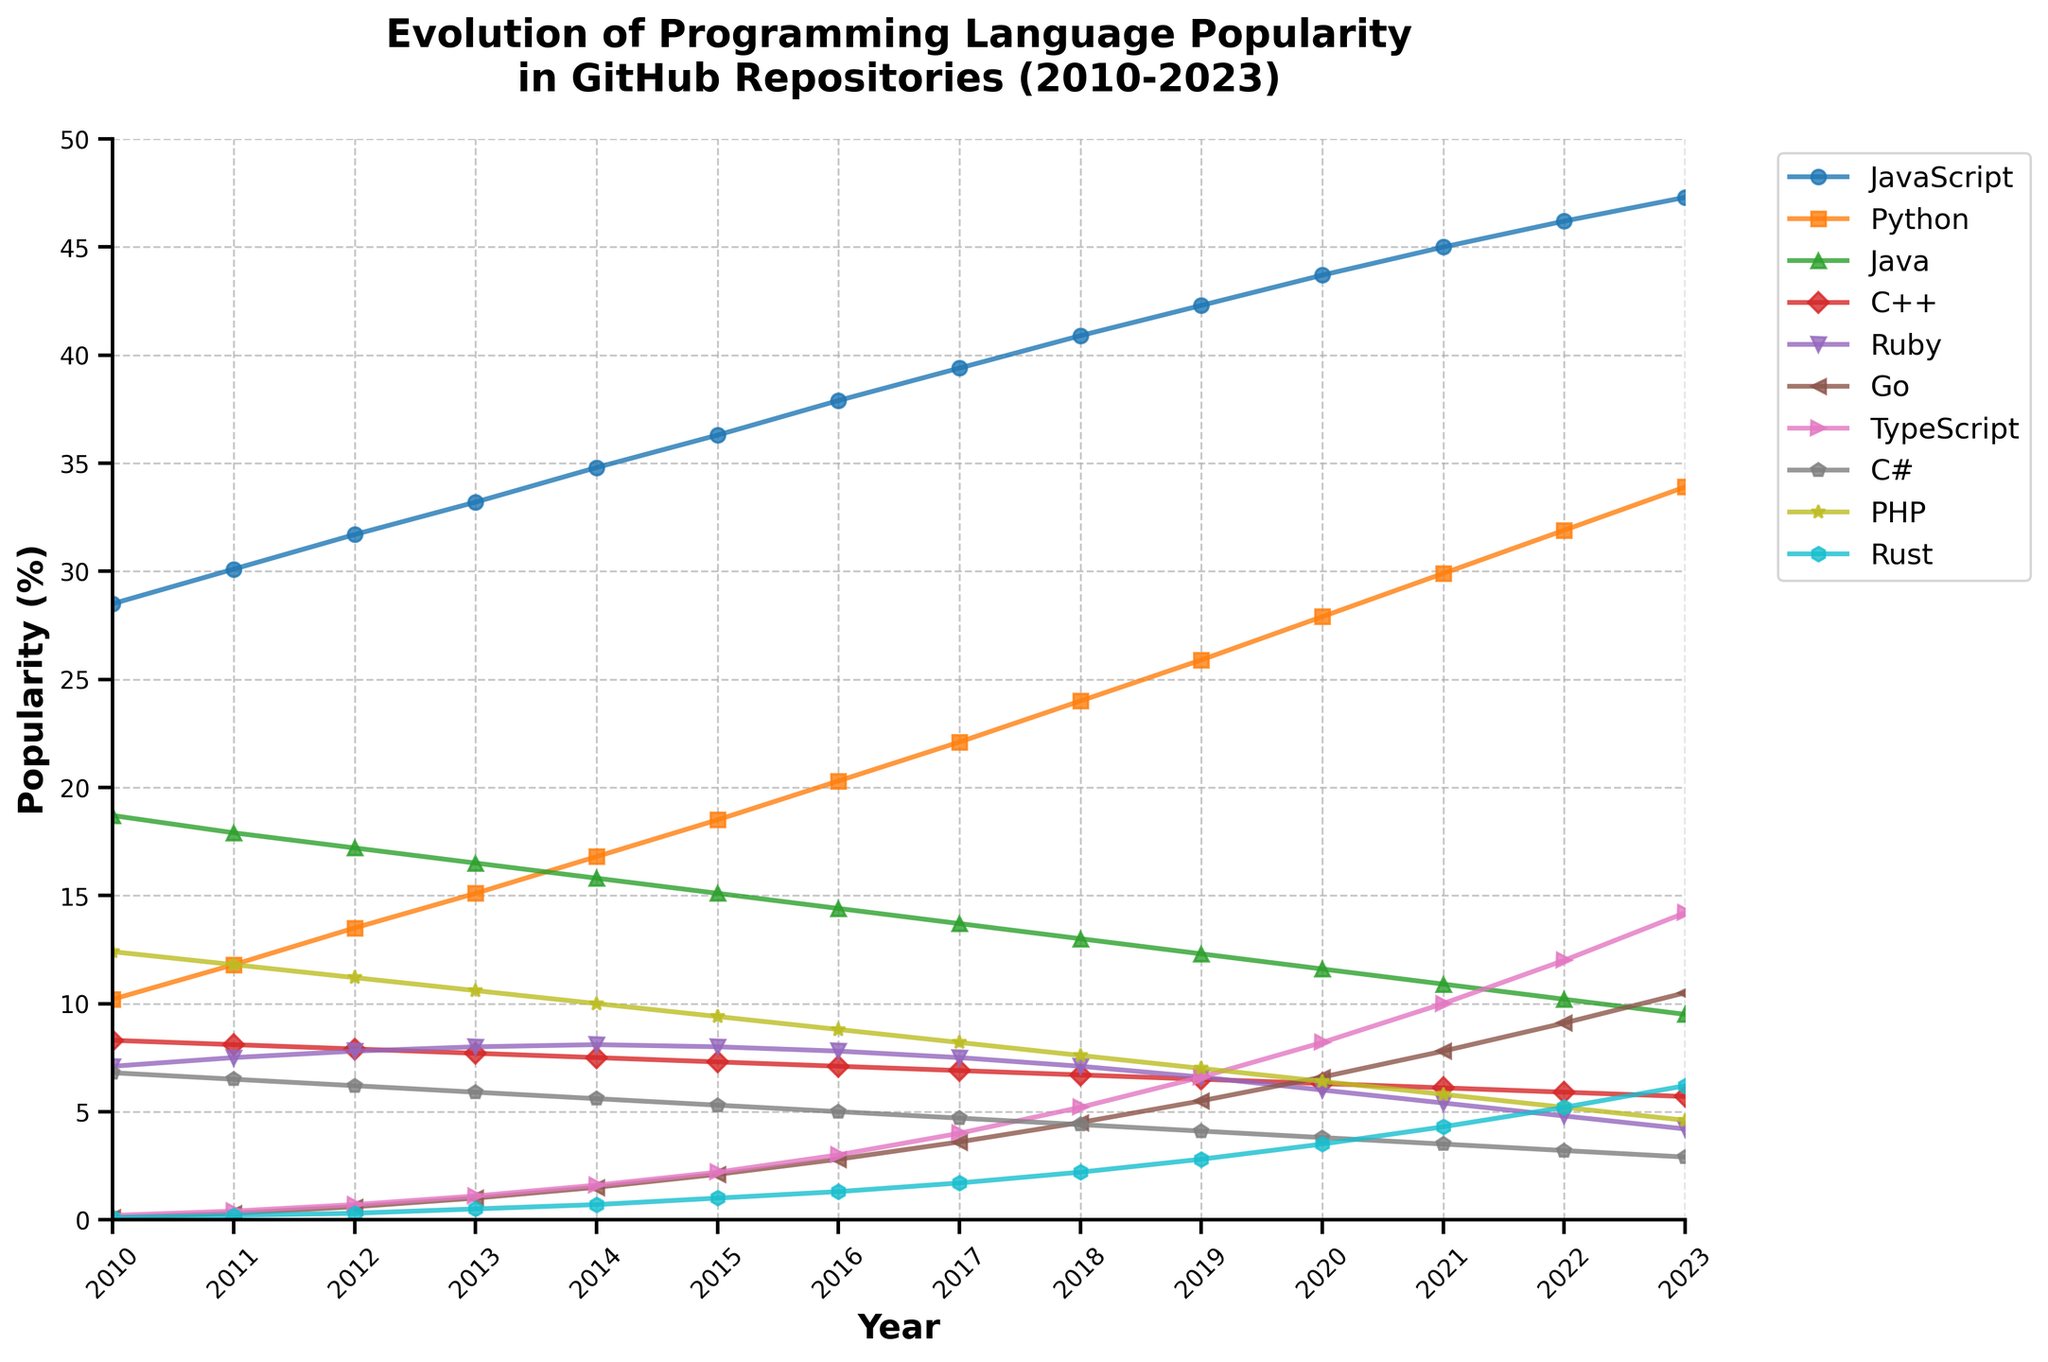What's the most popular programming language in 2023? In the figure, the line for JavaScript is the highest in 2023, indicating it has the highest popularity percentage.
Answer: JavaScript How did the popularity of Go change from 2010 to 2023? In 2010, Go's popularity was very low at 0.1%. Over the years, the figure shows a steady increase, reaching 10.5% in 2023. The difference between the two years is 10.5 - 0.1 = 10.4%.
Answer: Increased by 10.4% Which language experienced the sharpest rise in popularity between 2010 and 2023? By observing the slopes of the lines in the figure, TypeScript shows a significant rise from 0.2% in 2010 to 14.2% in 2023. The difference is 14.2 - 0.2 = 14%.
Answer: TypeScript Compare the popularity trends of Python and Java from 2010 to 2023. Python's line shows a steady increase from 10.2% to 33.9%, while Java's line shows a decrease from 18.7% to 9.5% over the same period. Python's popularity increased, while Java's decreased.
Answer: Python increased, Java decreased What year did Rust surpass PHP in popularity? By comparing the points where Rust's line crosses above PHP's line, the figure shows Rust surpassing PHP in 2022.
Answer: 2022 What's the average popularity of C++ from 2010 to 2023? The popularity values for C++ from 2010 to 2023 are [8.3, 8.1, 7.9, 7.7, 7.5, 7.3, 7.1, 6.9, 6.7, 6.5, 6.3, 6.1, 5.9, 5.7]. The sum is 101.5 and the average is 101.5 / 14 = 7.25.
Answer: 7.25 Which language shows the most consistent popularity trend and why? Ruby shows a relatively flat line around 7-8% without major spikes or drops, indicating a consistent trend compared to other languages with fluctuating trends.
Answer: Ruby Identify the two programming languages with the closest popularity percentages in 2023. In 2023, PHP has a popularity of 4.6% and C# has 2.9%, making them relatively close. However, Ruby at 4.2% is closer to PHP at 4.6%. The difference is 0.4%.
Answer: Ruby and PHP Which programming language had a sudden surge in popularity after 2017? TypeScript shows a noticeable increase after 2017, particularly from 4.0% in 2017 to 14.2% in 2023.
Answer: TypeScript What is the percentage difference in popularity between JavaScript and Python in 2023? In 2023, JavaScript has 47.3% popularity and Python has 33.9%. The difference is 47.3 - 33.9 = 13.4%.
Answer: 13.4% 